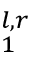<formula> <loc_0><loc_0><loc_500><loc_500>_ { 1 } ^ { l , r }</formula> 